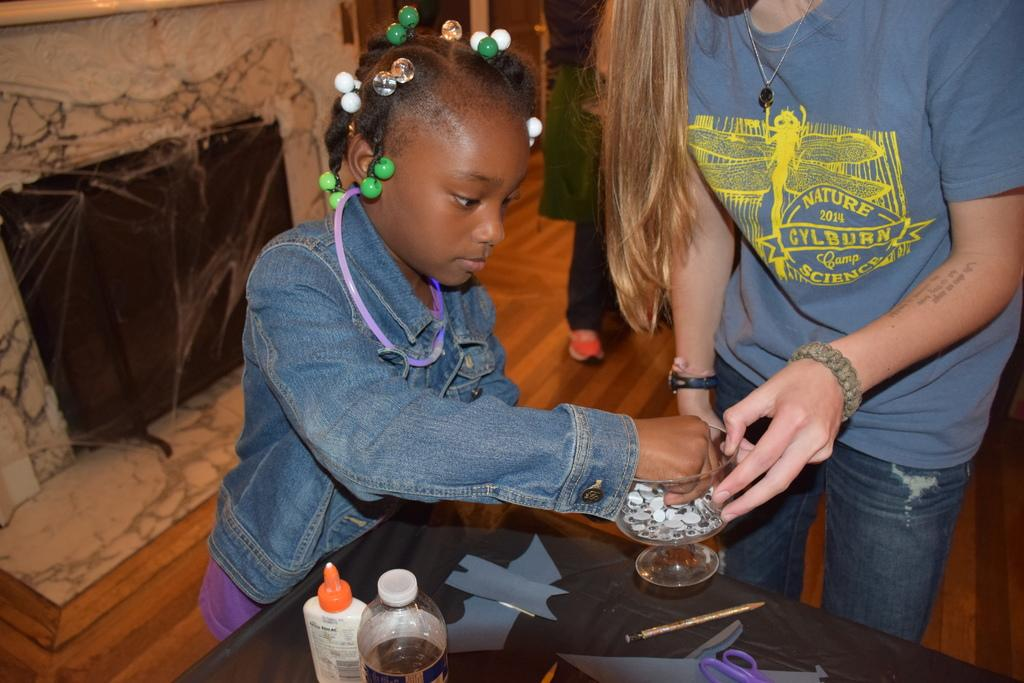Who are the people in the image? There is a girl and a woman in the image. What is present in the image besides the people? There is a table, a glass, and bottles in the image. Where are the bottles located in the image? The bottles are on the table in the image. What might be used for drinking in the image? The glass on the table might be used for drinking. What type of glue is being used by the girl in the image? There is no glue present in the image, and the girl is not using any glue. How does the woman feel about the situation in the image? The image does not provide any information about the woman's feelings or emotions, so we cannot determine how she feels about the situation. 